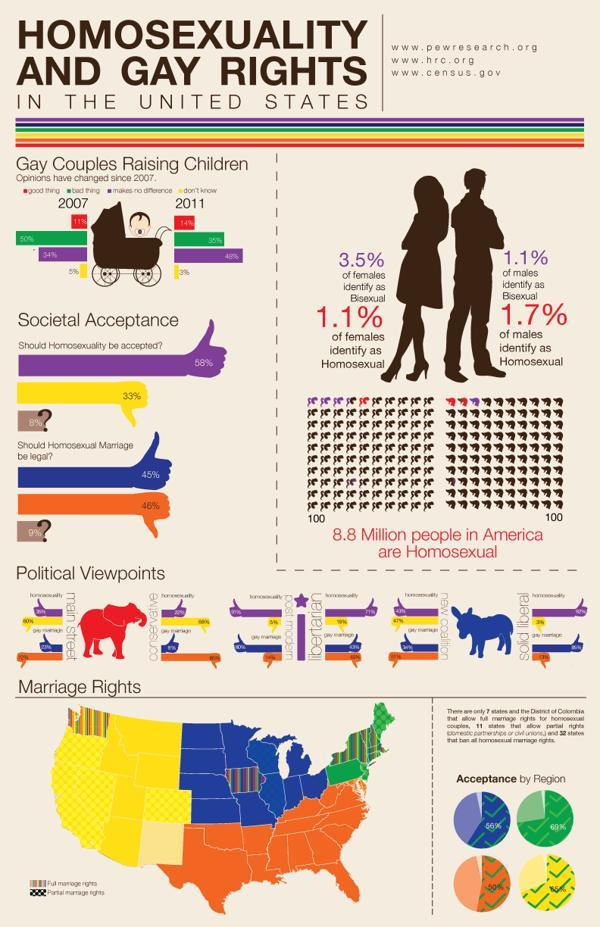What percentage of females are identified as bisexual in the United States?
Answer the question with a short phrase. 3.5% What percentage of males are identified as bisexual in the United States? 1.1% What percentage of people think that homosexuality should not be accepted in the United States? 33% What percentage of people think that homosexual marriages should be made legal in the United States? 45% What percentage of males are identified as homosexual in the United States? 1.7% What is the total homosexual population in the United States? 8.8 Million What percentage of people think that homosexuality should be accepted in the United States? 58% 